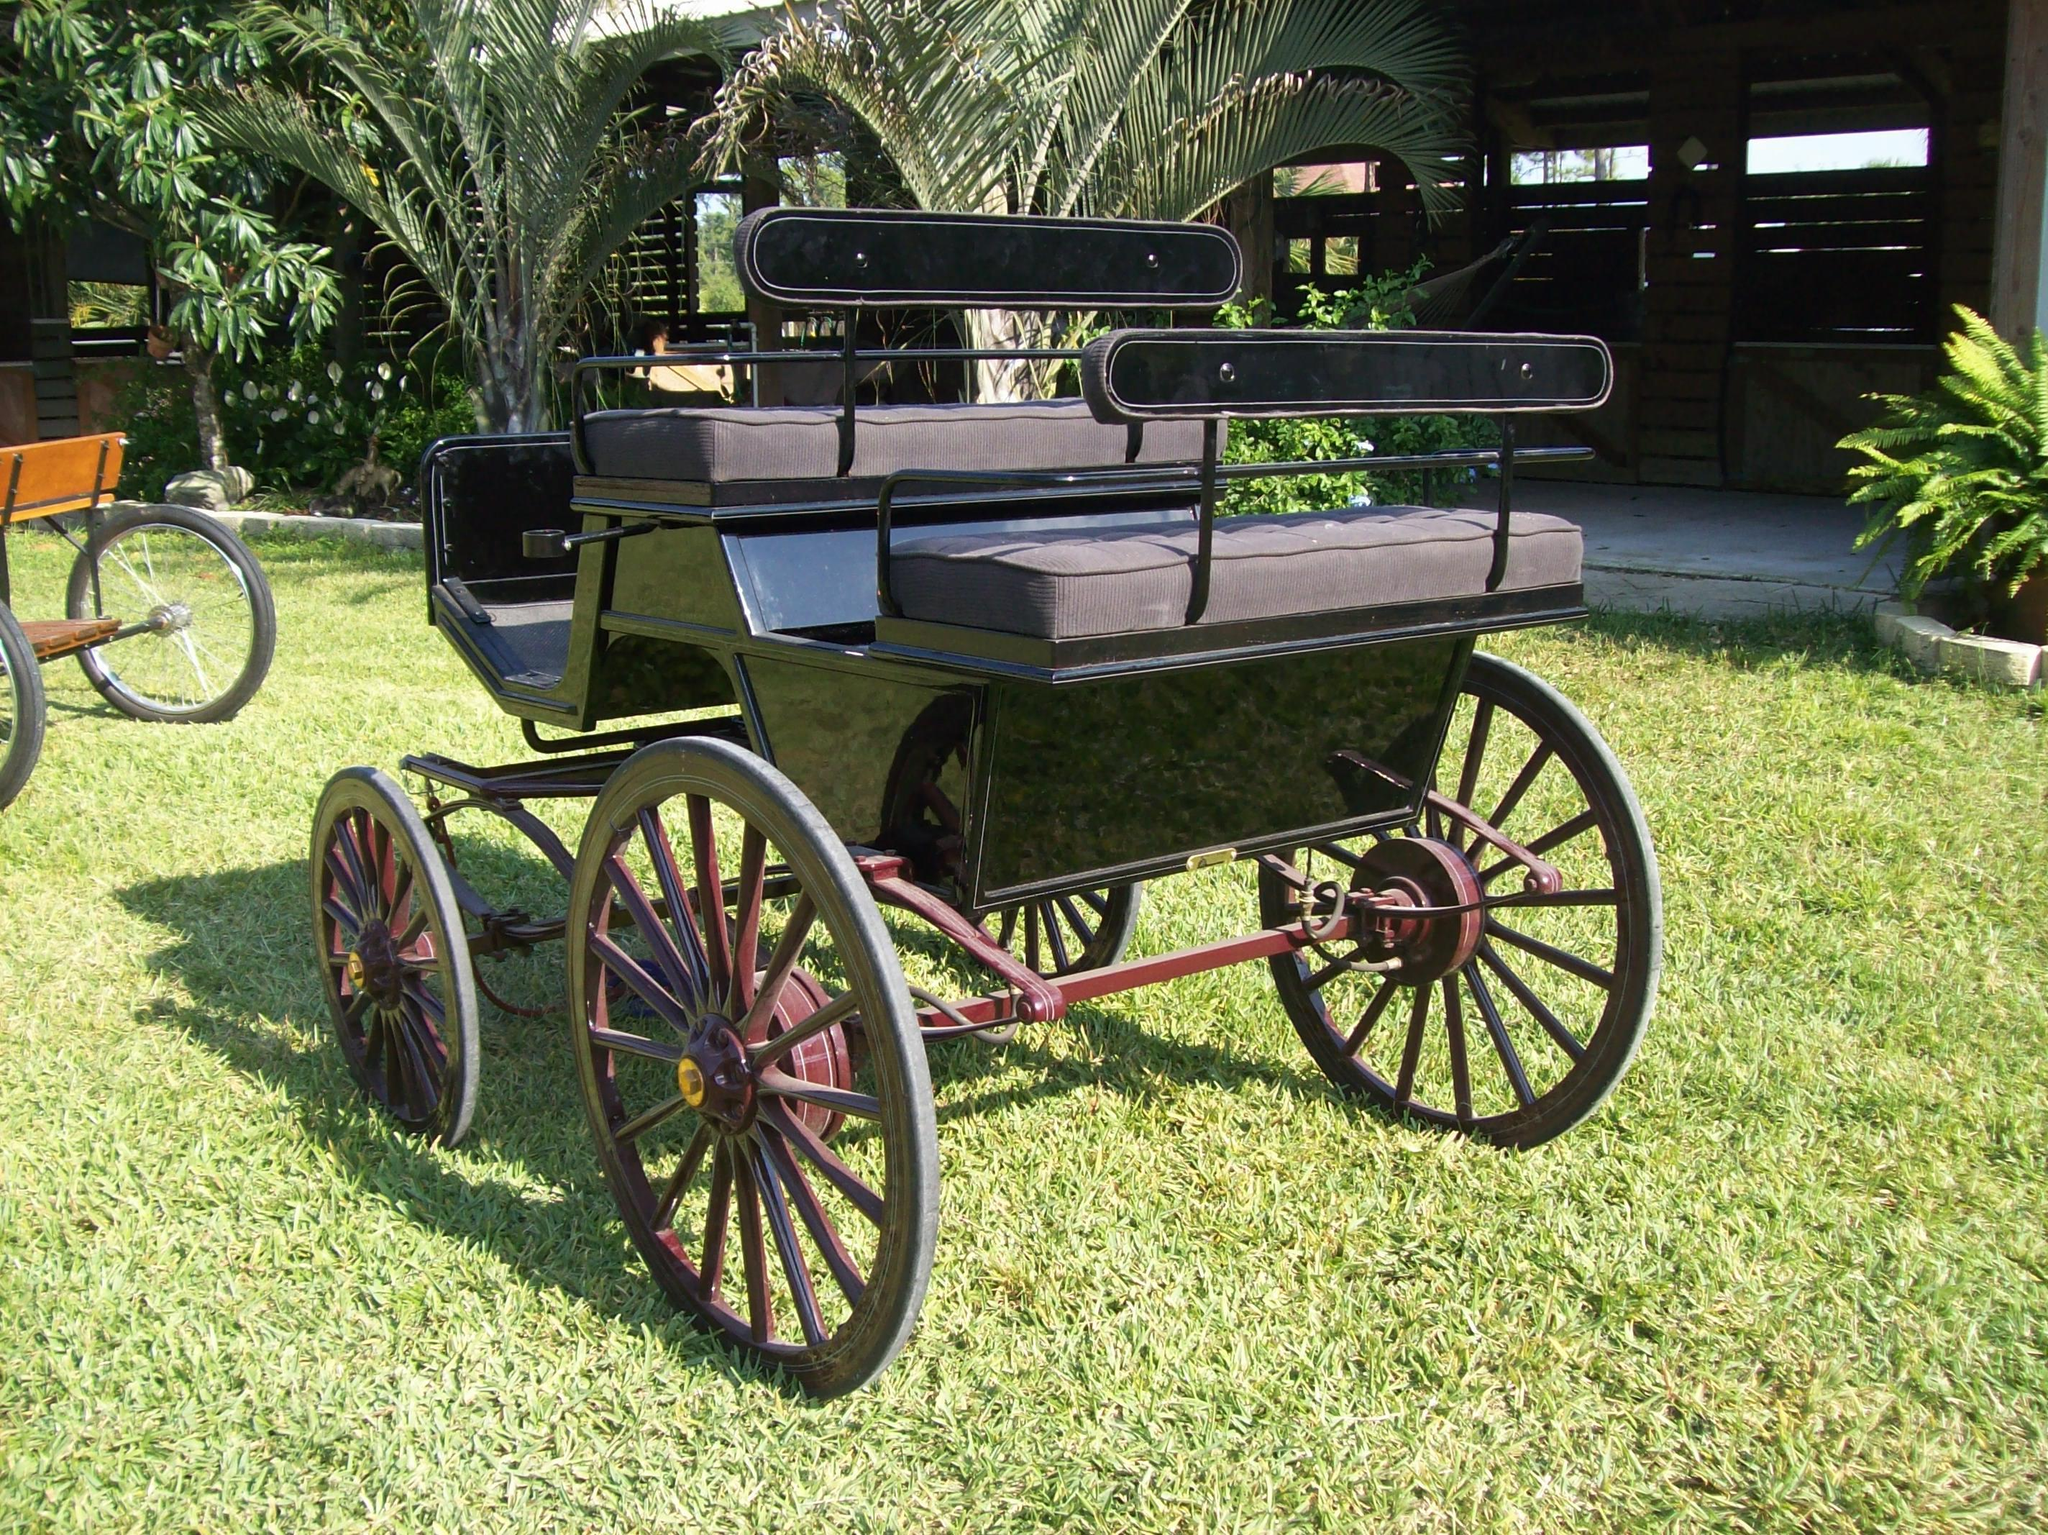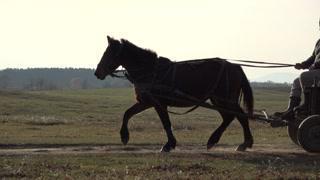The first image is the image on the left, the second image is the image on the right. Assess this claim about the two images: "An image shows a type of cart with no horse attached.". Correct or not? Answer yes or no. Yes. The first image is the image on the left, the second image is the image on the right. For the images shown, is this caption "In 1 of the images, 1 carriage has no horse pulling it." true? Answer yes or no. Yes. 